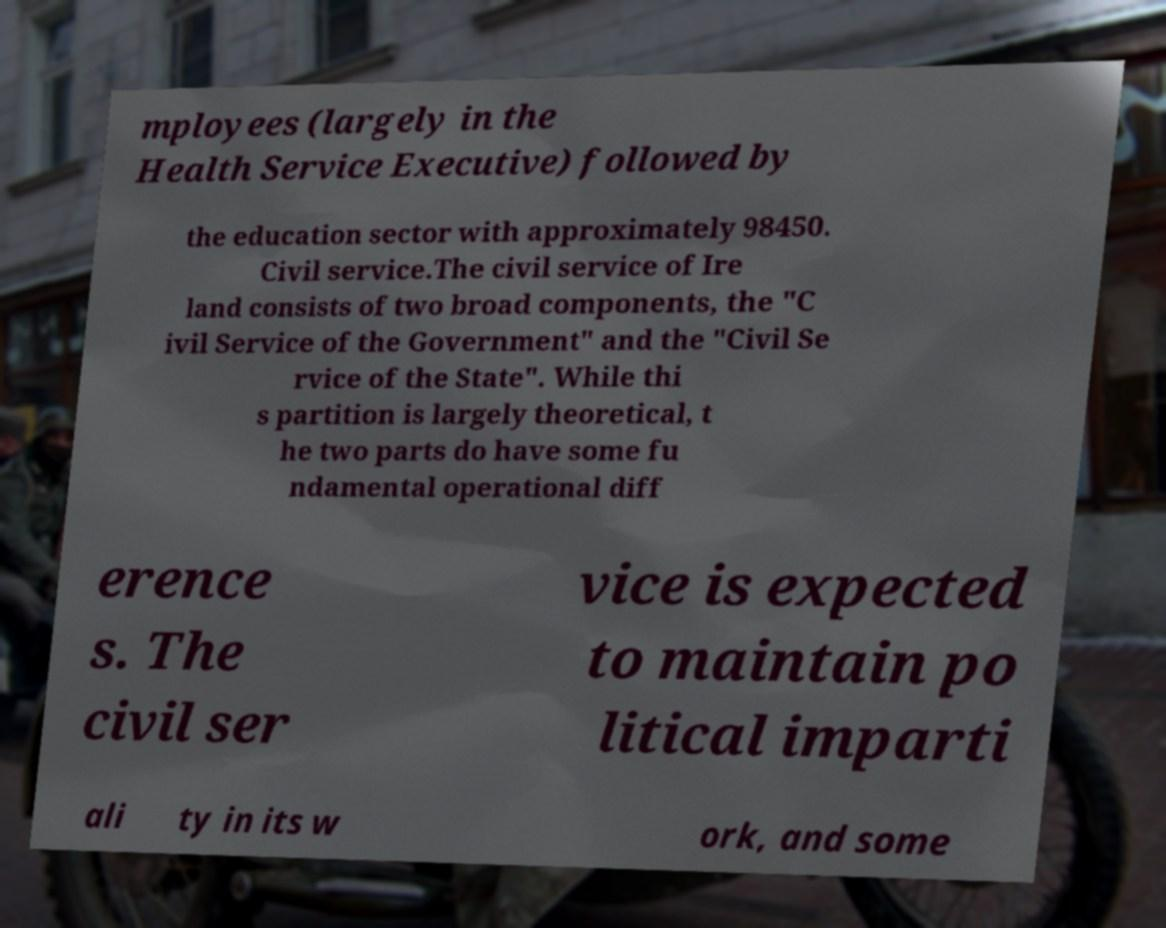I need the written content from this picture converted into text. Can you do that? mployees (largely in the Health Service Executive) followed by the education sector with approximately 98450. Civil service.The civil service of Ire land consists of two broad components, the "C ivil Service of the Government" and the "Civil Se rvice of the State". While thi s partition is largely theoretical, t he two parts do have some fu ndamental operational diff erence s. The civil ser vice is expected to maintain po litical imparti ali ty in its w ork, and some 